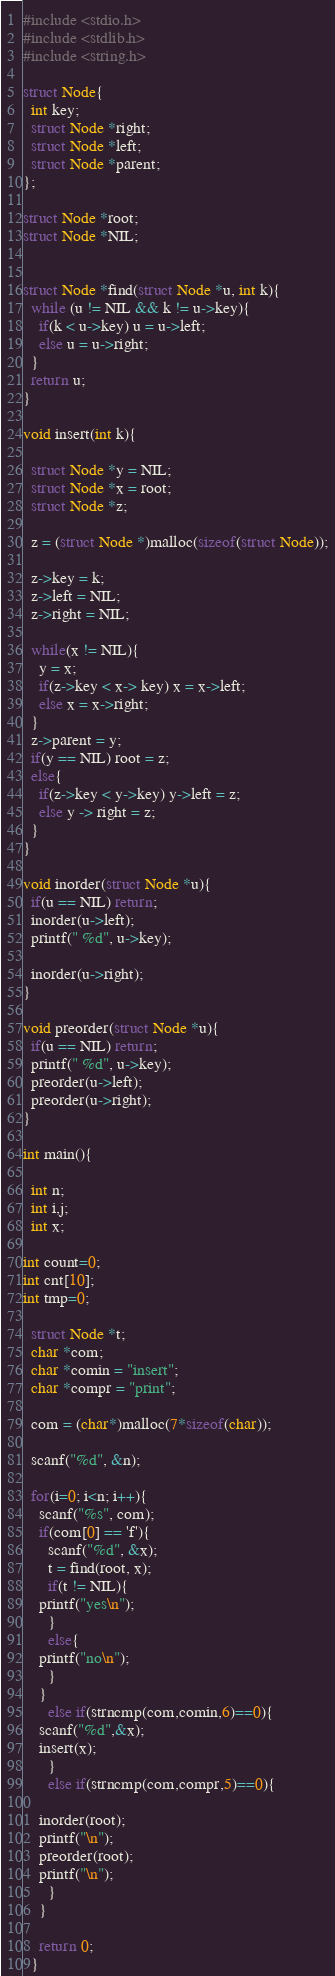<code> <loc_0><loc_0><loc_500><loc_500><_C_>#include <stdio.h>
#include <stdlib.h>
#include <string.h>

struct Node{
  int key;
  struct Node *right;
  struct Node *left;
  struct Node *parent;
};

struct Node *root;
struct Node *NIL;


struct Node *find(struct Node *u, int k){
  while (u != NIL && k != u->key){
    if(k < u->key) u = u->left;
    else u = u->right;
  }
  return u;
}

void insert(int k){

  struct Node *y = NIL;
  struct Node *x = root;
  struct Node *z;

  z = (struct Node *)malloc(sizeof(struct Node));

  z->key = k;
  z->left = NIL;
  z->right = NIL;

  while(x != NIL){
    y = x;
    if(z->key < x-> key) x = x->left;
    else x = x->right;
  }
  z->parent = y;
  if(y == NIL) root = z;
  else{
    if(z->key < y->key) y->left = z;
    else y -> right = z;
  }
}

void inorder(struct Node *u){
  if(u == NIL) return;
  inorder(u->left);
  printf(" %d", u->key);
 
  inorder(u->right);
}

void preorder(struct Node *u){
  if(u == NIL) return;
  printf(" %d", u->key);
  preorder(u->left);
  preorder(u->right);
}

int main(){

  int n;
  int i,j;
  int x;
  
int count=0;
int cnt[10];
int tmp=0;

  struct Node *t;
  char *com;
  char *comin = "insert";
  char *compr = "print";

  com = (char*)malloc(7*sizeof(char));  

  scanf("%d", &n);

  for(i=0; i<n; i++){
    scanf("%s", com);
    if(com[0] == 'f'){
      scanf("%d", &x);
      t = find(root, x);
      if(t != NIL){
	printf("yes\n");
      }
      else{
	printf("no\n");
      }
    }
      else if(strncmp(com,comin,6)==0){
	scanf("%d",&x);
	insert(x);
      }
      else if(strncmp(com,compr,5)==0){

	inorder(root);
	printf("\n");
	preorder(root);
	printf("\n");
      }
    }

    return 0;
  }

</code> 